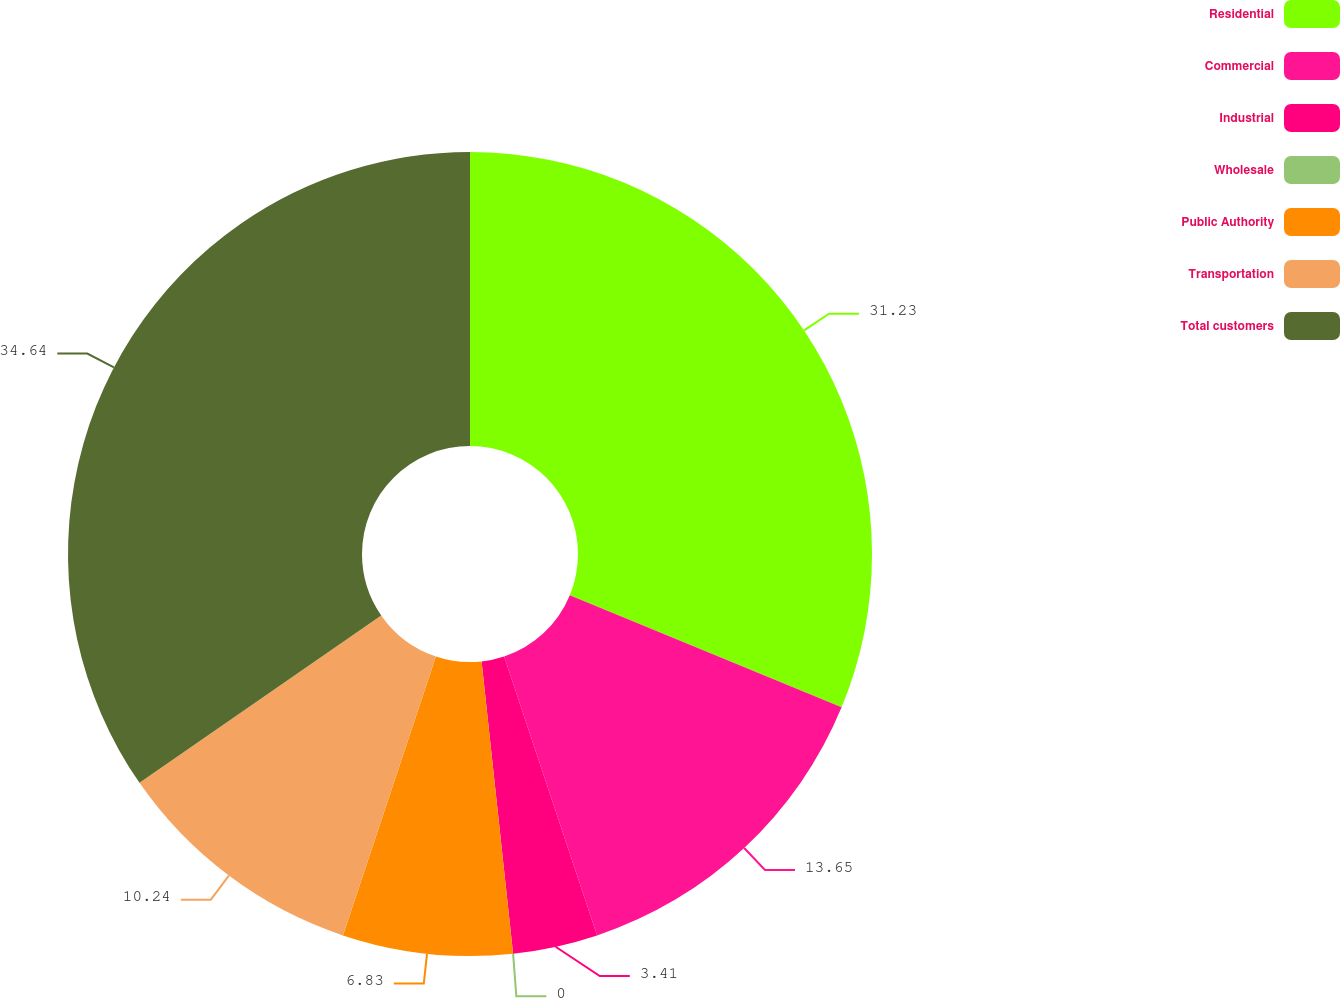Convert chart to OTSL. <chart><loc_0><loc_0><loc_500><loc_500><pie_chart><fcel>Residential<fcel>Commercial<fcel>Industrial<fcel>Wholesale<fcel>Public Authority<fcel>Transportation<fcel>Total customers<nl><fcel>31.23%<fcel>13.65%<fcel>3.41%<fcel>0.0%<fcel>6.83%<fcel>10.24%<fcel>34.64%<nl></chart> 